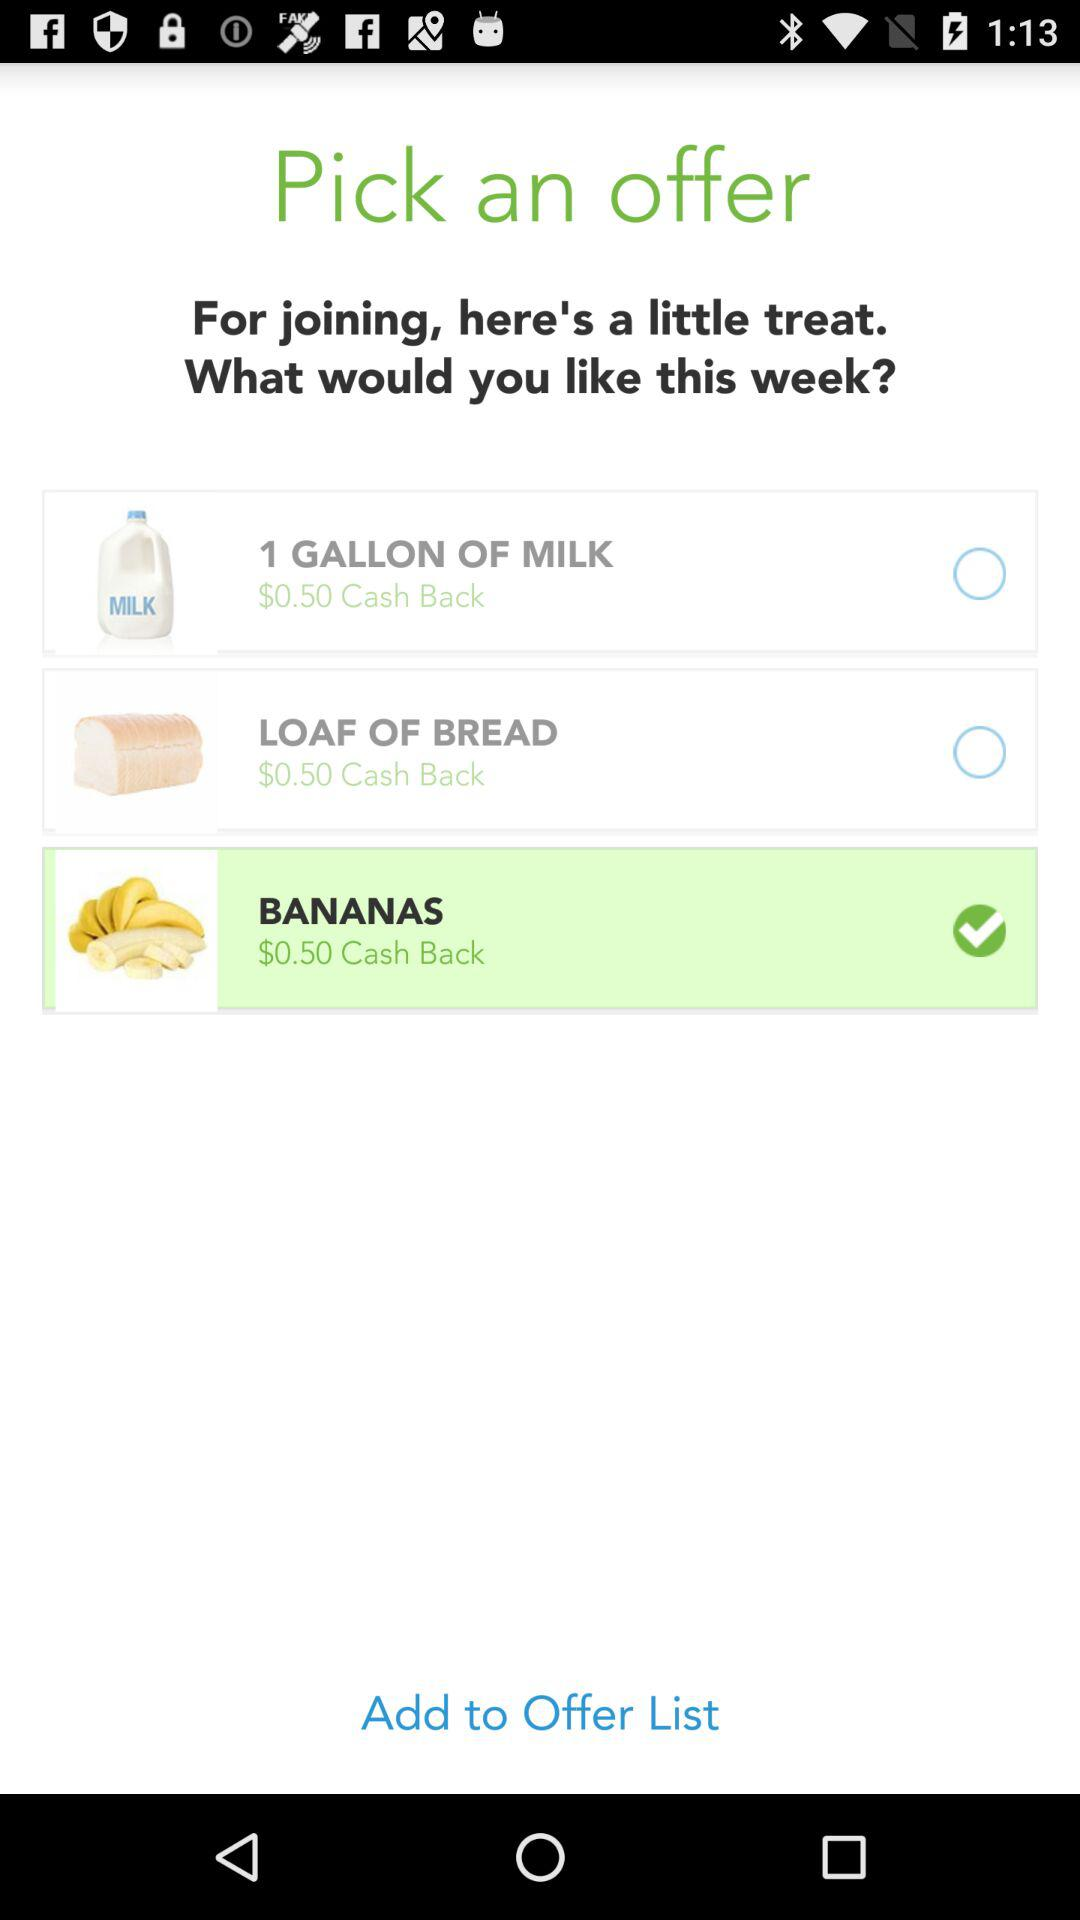Which item was selected to be added to the offer list? The selected item was "BANANAS". 